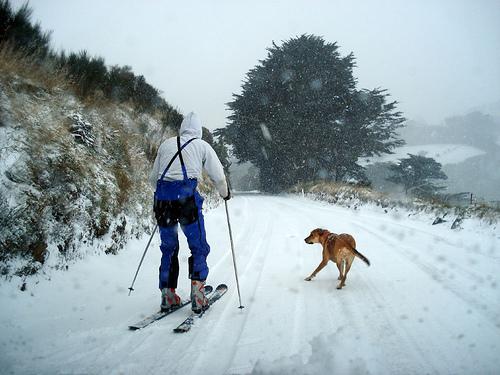Is this man being chased?
Give a very brief answer. No. What kind of animal is standing in the snow?
Quick response, please. Dog. Is it snowing?
Answer briefly. Yes. What is the color of the dog?
Short answer required. Brown. 